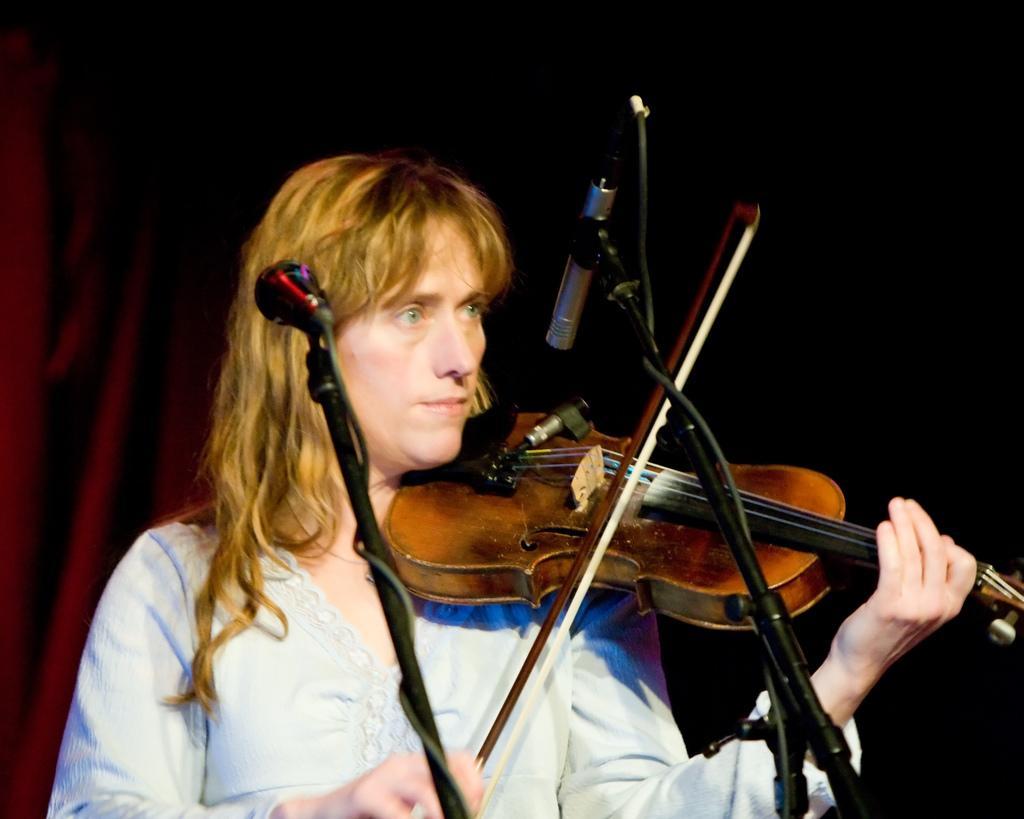In one or two sentences, can you explain what this image depicts? In this image, I can see the woman standing and playing the violin. I can see the miles attached to the mike stands. This looks like a cloth, which is hanging. The background looks dark. 